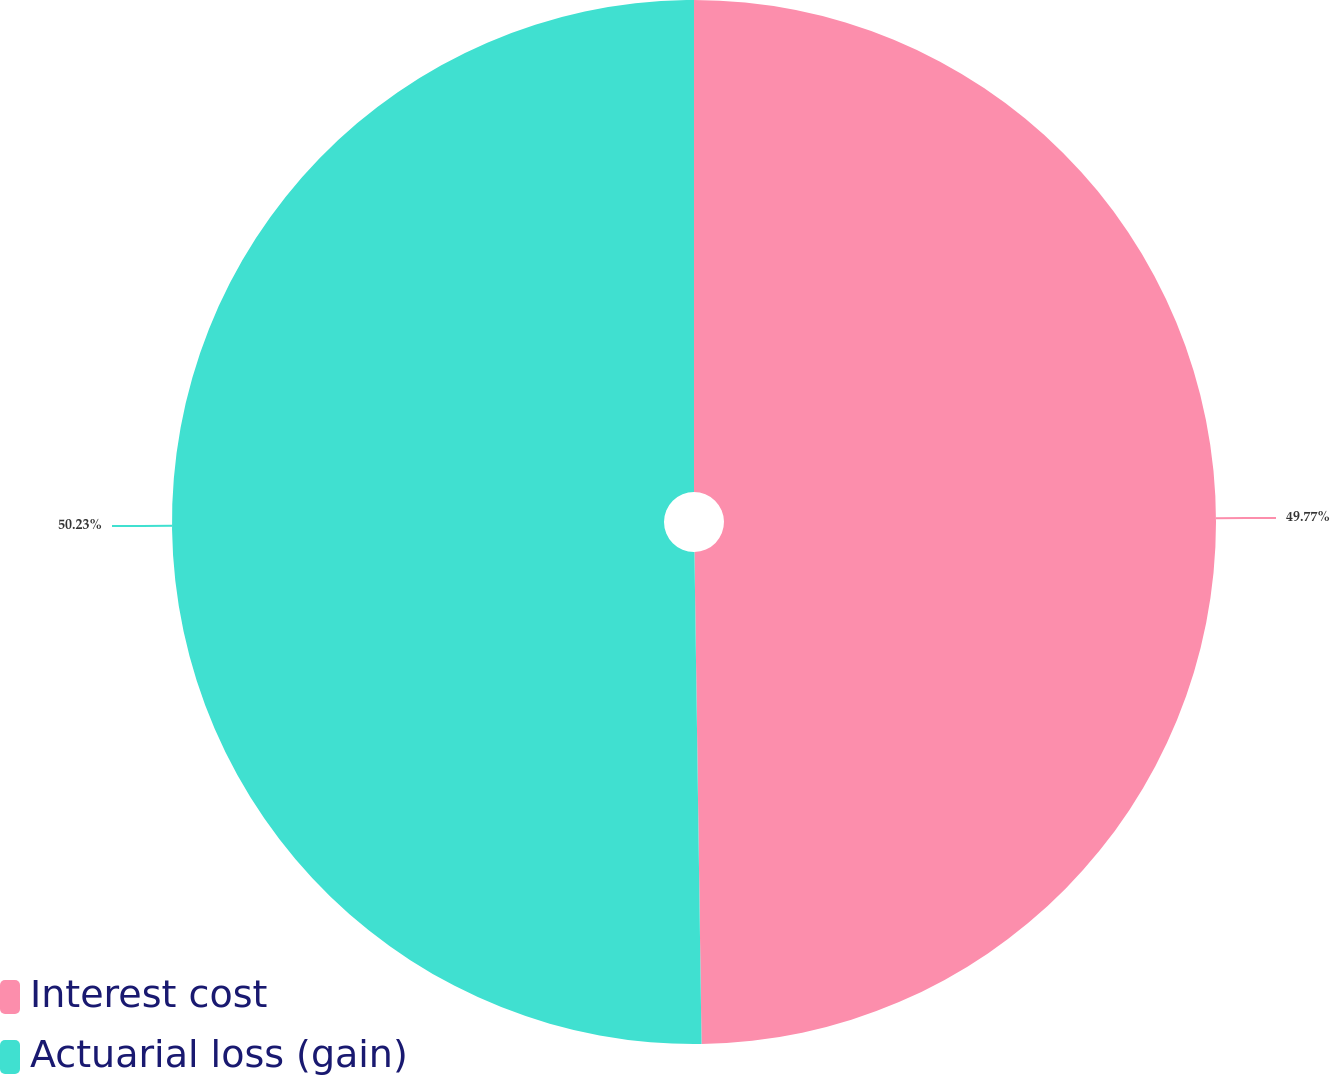<chart> <loc_0><loc_0><loc_500><loc_500><pie_chart><fcel>Interest cost<fcel>Actuarial loss (gain)<nl><fcel>49.77%<fcel>50.23%<nl></chart> 